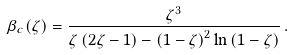<formula> <loc_0><loc_0><loc_500><loc_500>\beta _ { c } ( \zeta ) = \frac { \zeta ^ { 3 } } { \zeta \left ( 2 \zeta - 1 \right ) - \left ( 1 - \zeta \right ) ^ { 2 } \ln \left ( 1 - \zeta \right ) } \, .</formula> 